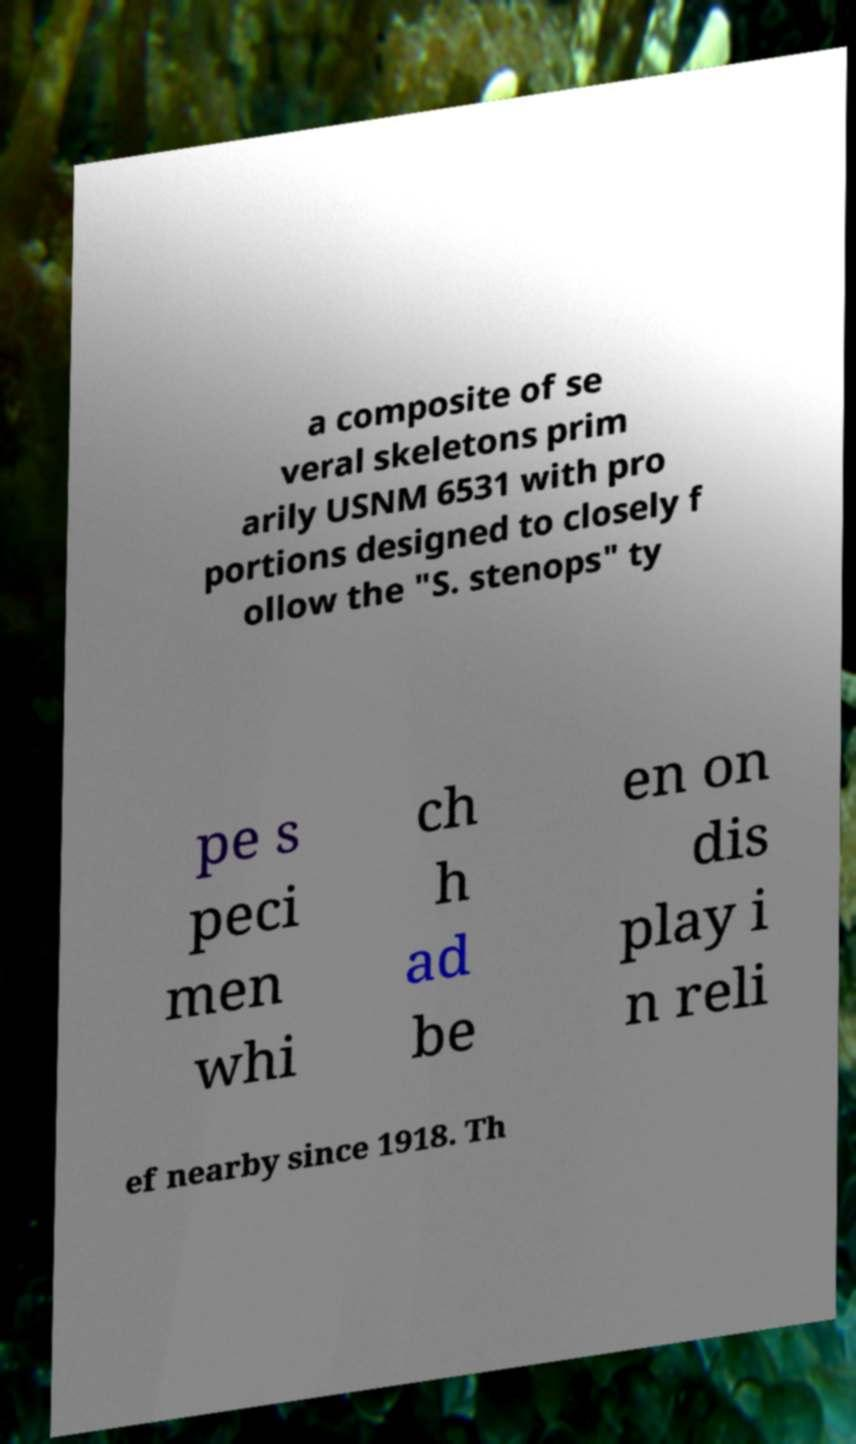Could you assist in decoding the text presented in this image and type it out clearly? a composite of se veral skeletons prim arily USNM 6531 with pro portions designed to closely f ollow the "S. stenops" ty pe s peci men whi ch h ad be en on dis play i n reli ef nearby since 1918. Th 